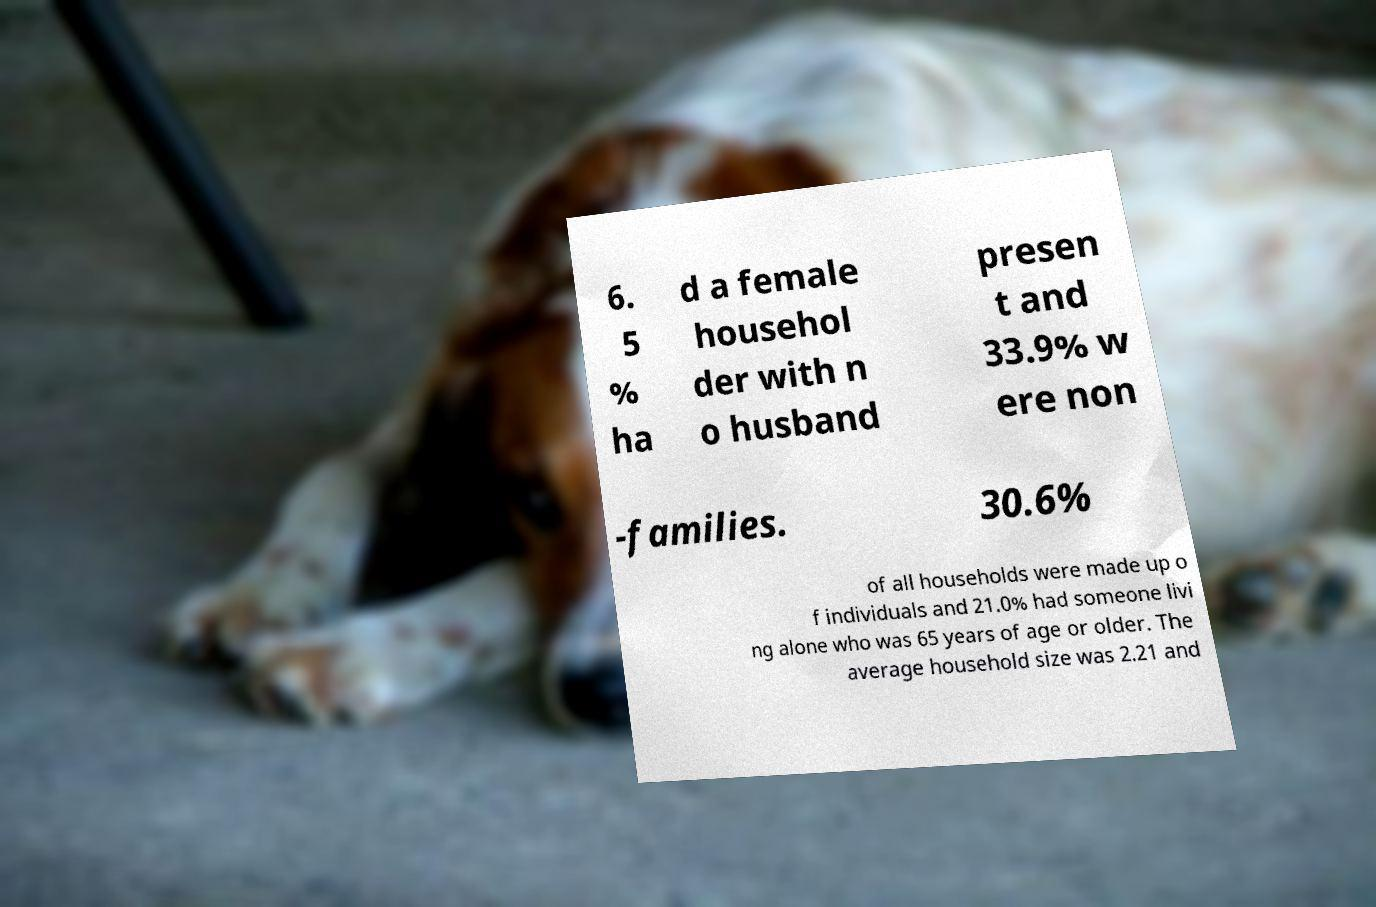Could you extract and type out the text from this image? 6. 5 % ha d a female househol der with n o husband presen t and 33.9% w ere non -families. 30.6% of all households were made up o f individuals and 21.0% had someone livi ng alone who was 65 years of age or older. The average household size was 2.21 and 